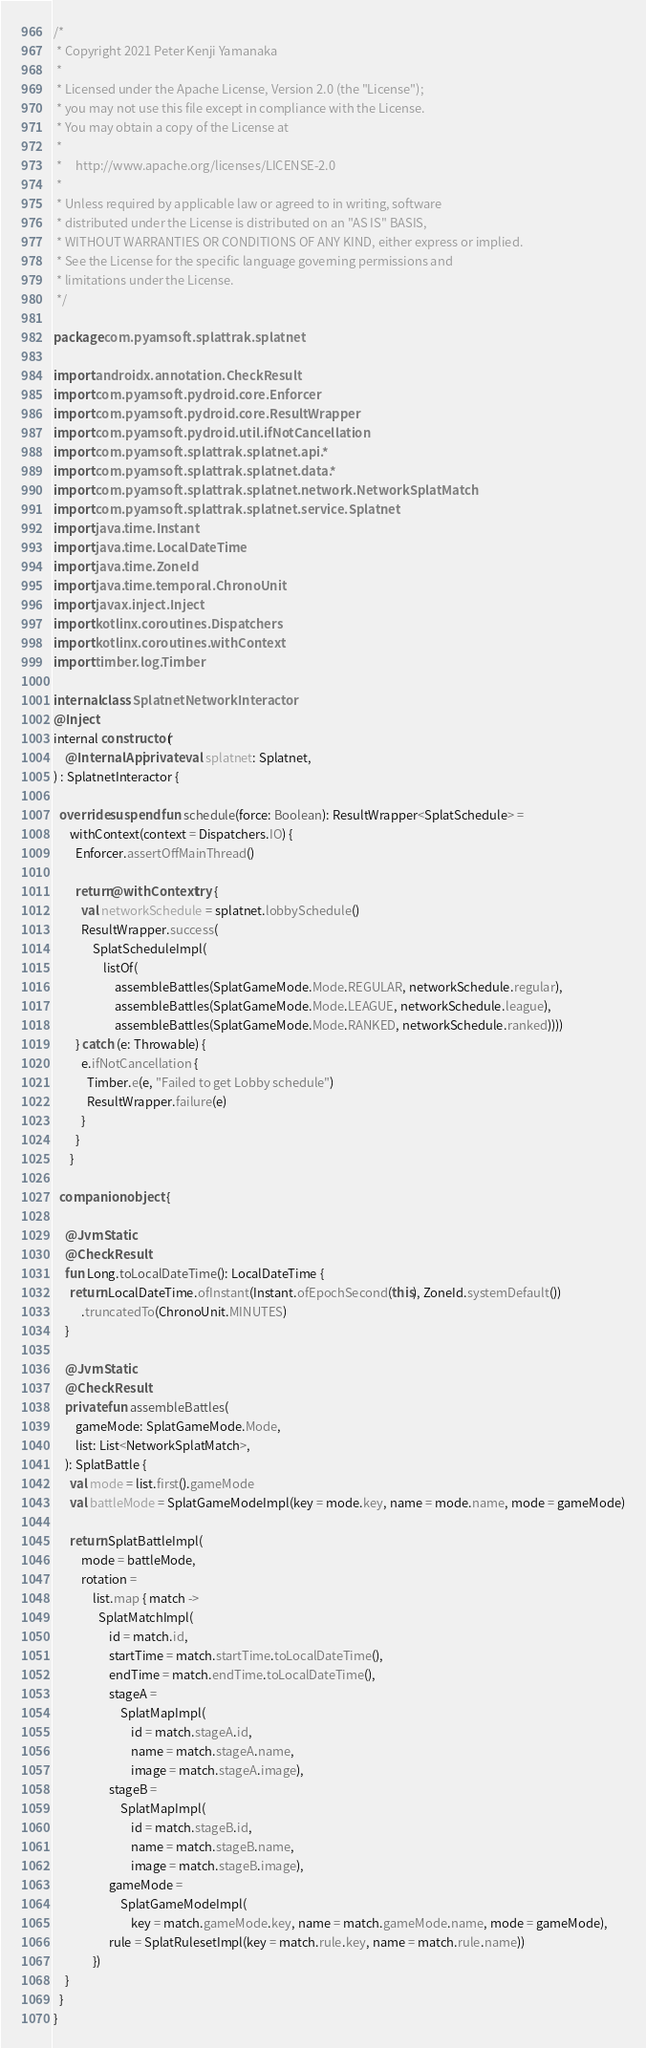<code> <loc_0><loc_0><loc_500><loc_500><_Kotlin_>/*
 * Copyright 2021 Peter Kenji Yamanaka
 *
 * Licensed under the Apache License, Version 2.0 (the "License");
 * you may not use this file except in compliance with the License.
 * You may obtain a copy of the License at
 *
 *     http://www.apache.org/licenses/LICENSE-2.0
 *
 * Unless required by applicable law or agreed to in writing, software
 * distributed under the License is distributed on an "AS IS" BASIS,
 * WITHOUT WARRANTIES OR CONDITIONS OF ANY KIND, either express or implied.
 * See the License for the specific language governing permissions and
 * limitations under the License.
 */

package com.pyamsoft.splattrak.splatnet

import androidx.annotation.CheckResult
import com.pyamsoft.pydroid.core.Enforcer
import com.pyamsoft.pydroid.core.ResultWrapper
import com.pyamsoft.pydroid.util.ifNotCancellation
import com.pyamsoft.splattrak.splatnet.api.*
import com.pyamsoft.splattrak.splatnet.data.*
import com.pyamsoft.splattrak.splatnet.network.NetworkSplatMatch
import com.pyamsoft.splattrak.splatnet.service.Splatnet
import java.time.Instant
import java.time.LocalDateTime
import java.time.ZoneId
import java.time.temporal.ChronoUnit
import javax.inject.Inject
import kotlinx.coroutines.Dispatchers
import kotlinx.coroutines.withContext
import timber.log.Timber

internal class SplatnetNetworkInteractor
@Inject
internal constructor(
    @InternalApi private val splatnet: Splatnet,
) : SplatnetInteractor {

  override suspend fun schedule(force: Boolean): ResultWrapper<SplatSchedule> =
      withContext(context = Dispatchers.IO) {
        Enforcer.assertOffMainThread()

        return@withContext try {
          val networkSchedule = splatnet.lobbySchedule()
          ResultWrapper.success(
              SplatScheduleImpl(
                  listOf(
                      assembleBattles(SplatGameMode.Mode.REGULAR, networkSchedule.regular),
                      assembleBattles(SplatGameMode.Mode.LEAGUE, networkSchedule.league),
                      assembleBattles(SplatGameMode.Mode.RANKED, networkSchedule.ranked))))
        } catch (e: Throwable) {
          e.ifNotCancellation {
            Timber.e(e, "Failed to get Lobby schedule")
            ResultWrapper.failure(e)
          }
        }
      }

  companion object {

    @JvmStatic
    @CheckResult
    fun Long.toLocalDateTime(): LocalDateTime {
      return LocalDateTime.ofInstant(Instant.ofEpochSecond(this), ZoneId.systemDefault())
          .truncatedTo(ChronoUnit.MINUTES)
    }

    @JvmStatic
    @CheckResult
    private fun assembleBattles(
        gameMode: SplatGameMode.Mode,
        list: List<NetworkSplatMatch>,
    ): SplatBattle {
      val mode = list.first().gameMode
      val battleMode = SplatGameModeImpl(key = mode.key, name = mode.name, mode = gameMode)

      return SplatBattleImpl(
          mode = battleMode,
          rotation =
              list.map { match ->
                SplatMatchImpl(
                    id = match.id,
                    startTime = match.startTime.toLocalDateTime(),
                    endTime = match.endTime.toLocalDateTime(),
                    stageA =
                        SplatMapImpl(
                            id = match.stageA.id,
                            name = match.stageA.name,
                            image = match.stageA.image),
                    stageB =
                        SplatMapImpl(
                            id = match.stageB.id,
                            name = match.stageB.name,
                            image = match.stageB.image),
                    gameMode =
                        SplatGameModeImpl(
                            key = match.gameMode.key, name = match.gameMode.name, mode = gameMode),
                    rule = SplatRulesetImpl(key = match.rule.key, name = match.rule.name))
              })
    }
  }
}
</code> 